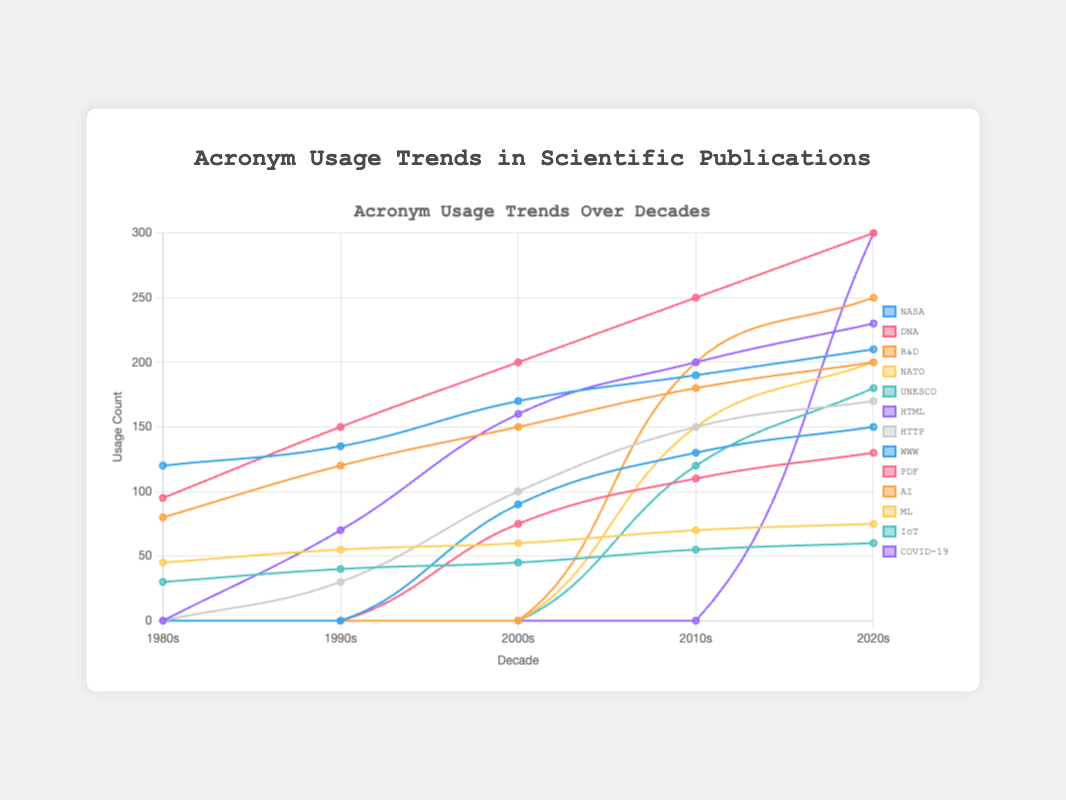Which acronym showed the highest increase in usage from the 1980s to the 2020s? To find the acronym with the highest increase in usage, we calculate the difference for each acronym using their usage counts in the 2020s and 1980s. The differences are: NASA (210-120=90), DNA (300-95=205), R&D (200-80=120), NATO (75-45=30), UNESCO (60-30=30). DNA has the highest increase of 205.
Answer: DNA Which two acronyms had almost equal usage in the 1990s? To find two acronyms with almost equal usage, we check the usage counts in the 1990s. NASA (135), DNA (150), HTML (70), R&D (120), NATO (55), UNESCO (40), HTTP (30). A close match within a small difference is UNESCO (40) and HTTP (30).
Answer: UNESCO and HTTP Identify the acronym that started being used in the 2000s and showed back-to-back increases in each subsequent decade. For this, examine acronyms that appear in the 2000s and ensure they show an increasing trend in each decade after that. Checking HTML (160-70-0), HTTP (100-30-0), WWW (90-0-0), PDF (75-0-0), all these acronyms except PDF and WWW showed back-to-back increases.
Answer: HTML, HTTP What is the total usage of AI, ML, and IoT in the 2020s? Sum the usage counts of AI, ML, and IoT in the 2020s. AI (250), ML (200), IoT (180). So, the total usage = 250 + 200 + 180 = 630.
Answer: 630 Which acronym first appeared in the 2020s and was immediately highly used? The new acronym "COVID-19" appears in the 2020s and has a usage count of 300, indicating a high usage right from its first appearance.
Answer: COVID-19 Compare the usage of DNA and NASA in the 2010s. Which was used more, and by how much? To compare DNA and NASA in the 2010s, observe their usage counts. DNA (250), NASA (190). The difference = 250 - 190 = 60; DNA is used more by 60.
Answer: DNA by 60 Which acronym had the smallest increase in usage from the 1990s to the 2010s? Calculate the usage increase for each acronym from the 1990s to the 2010s: DNA (250-150=100), NASA (190-135=55), HTML (200-70=130), R&D (180-120=60), NATO (70-55=15), UNESCO (55-40=15), HTTP (150-30=120). The smallest increase is for NATO and UNESCO, both by 15.
Answer: NATO and UNESCO What trend do we observe for the acronym "R&D" over the decades? Observe the usage counts of R&D in each decade: 1980s (80), 1990s (120), 2000s (150), 2010s (180), 2020s (200). R&D shows a consistently increasing trend every decade.
Answer: Increasing Which acronym had the highest usage in the 2020s and what was its usage count? From the 2020s data, identify the highest value. "DNA" and "COVID-19" both stand out with usage of 300.
Answer: DNA and COVID-19, usage 300 Which two acronyms were used exactly 150 times in a specific decade? Check each acronym and find those used 150 times in specific decades. In the 2010s, both HTML and HTTP had usage counts of 150.
Answer: HTML and HTTP 